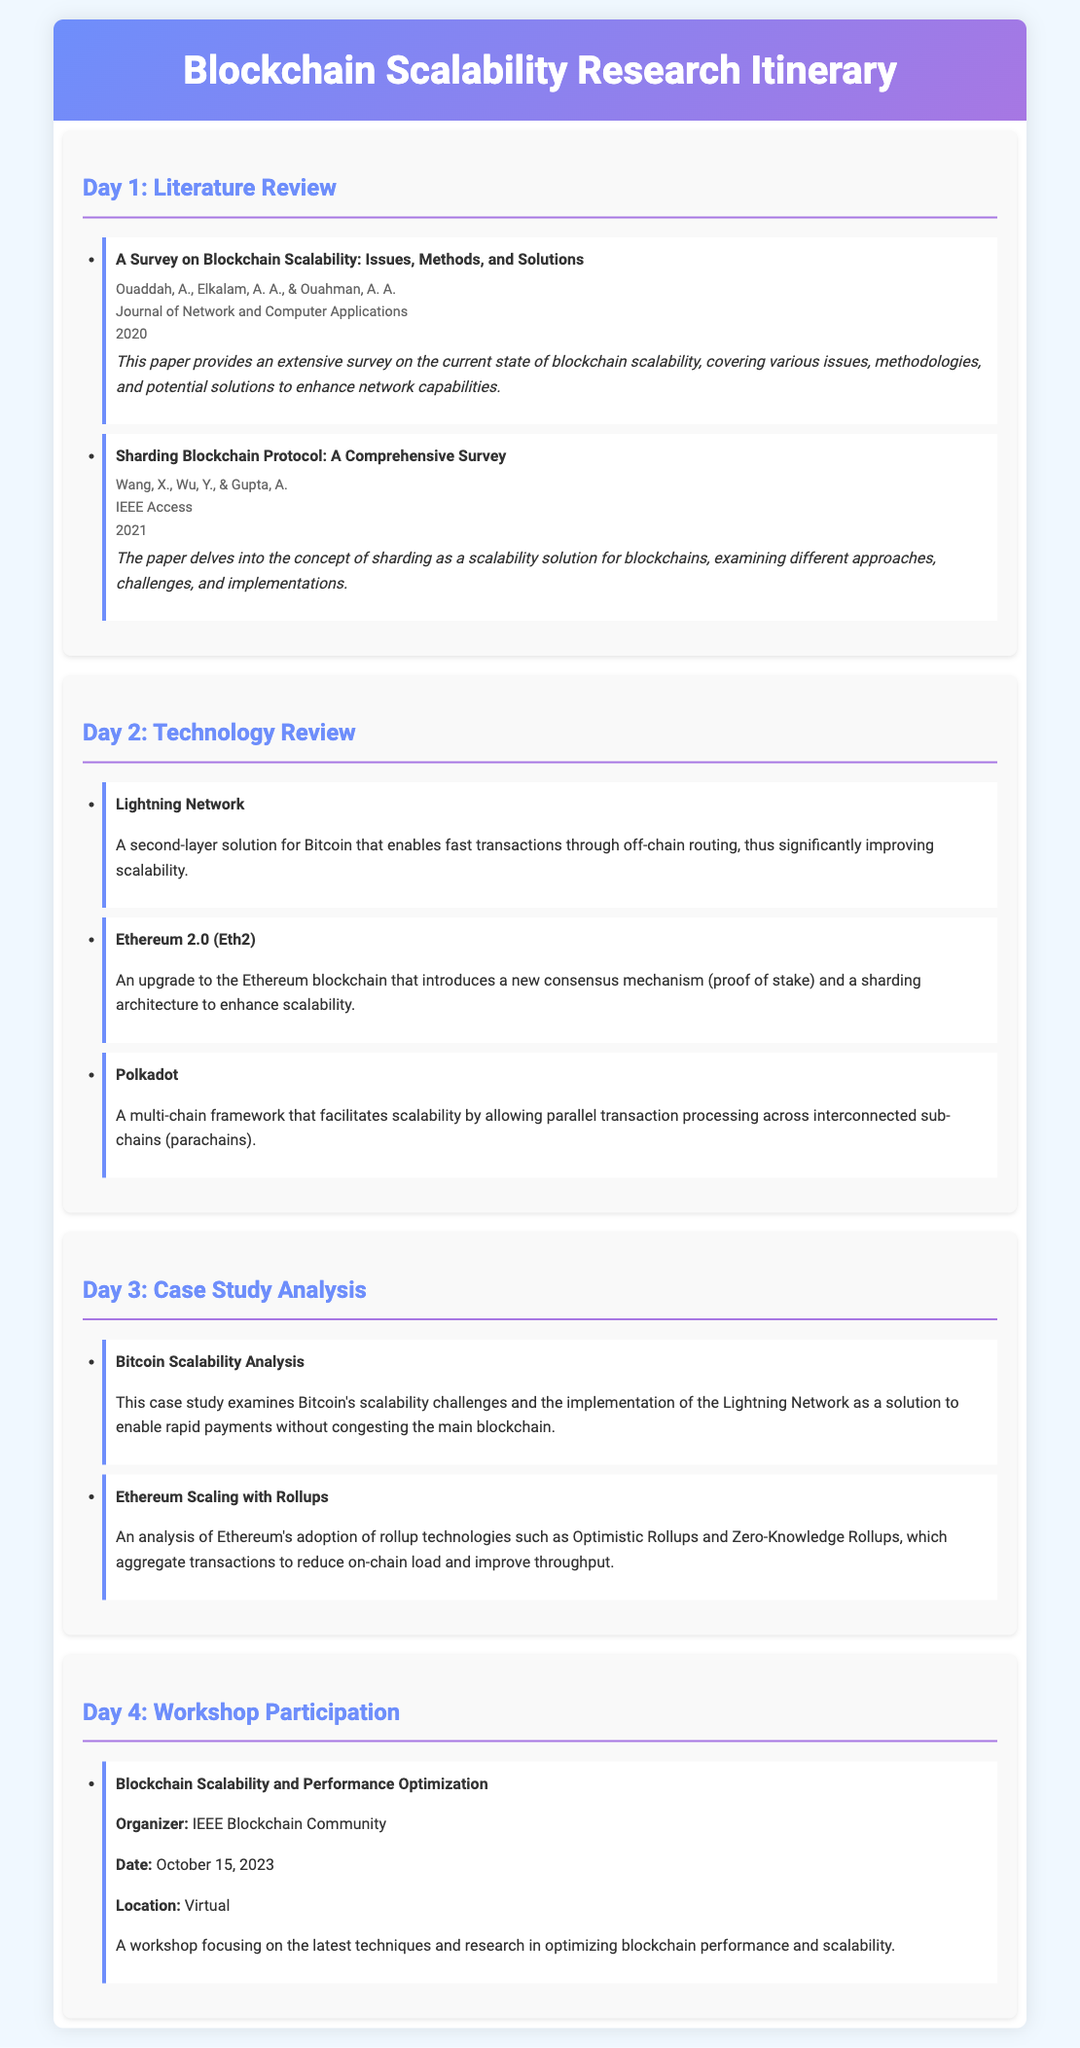What is the title of the first paper listed? The first paper listed under Day 1 is “A Survey on Blockchain Scalability: Issues, Methods, and Solutions.”
Answer: A Survey on Blockchain Scalability: Issues, Methods, and Solutions Who are the authors of the second paper? The authors of the second paper are Wang, X., Wu, Y., and Gupta, A.
Answer: Wang, X., Wu, Y., & Gupta, A In which journal was the first paper published? The first paper was published in the "Journal of Network and Computer Applications."
Answer: Journal of Network and Computer Applications What technology is described as a second-layer solution for Bitcoin? The technology described as a second-layer solution for Bitcoin is the "Lightning Network."
Answer: Lightning Network What is the primary focus of the workshop listed on Day 4? The primary focus of the workshop is on the latest techniques and research in optimizing blockchain performance and scalability.
Answer: Optimizing blockchain performance and scalability How many days are dedicated to the research itinerary? The research itinerary is dedicated to four days.
Answer: Four Which technology introduces a new consensus mechanism to enhance scalability? Ethereum 2.0 introduces a new consensus mechanism to enhance scalability.
Answer: Ethereum 2.0 What is the date of the workshop mentioned in the itinerary? The date of the workshop is October 15, 2023.
Answer: October 15, 2023 What topic does the second case study analyze? The second case study analyzes Ethereum's adoption of rollup technologies.
Answer: Ethereum's adoption of rollup technologies 